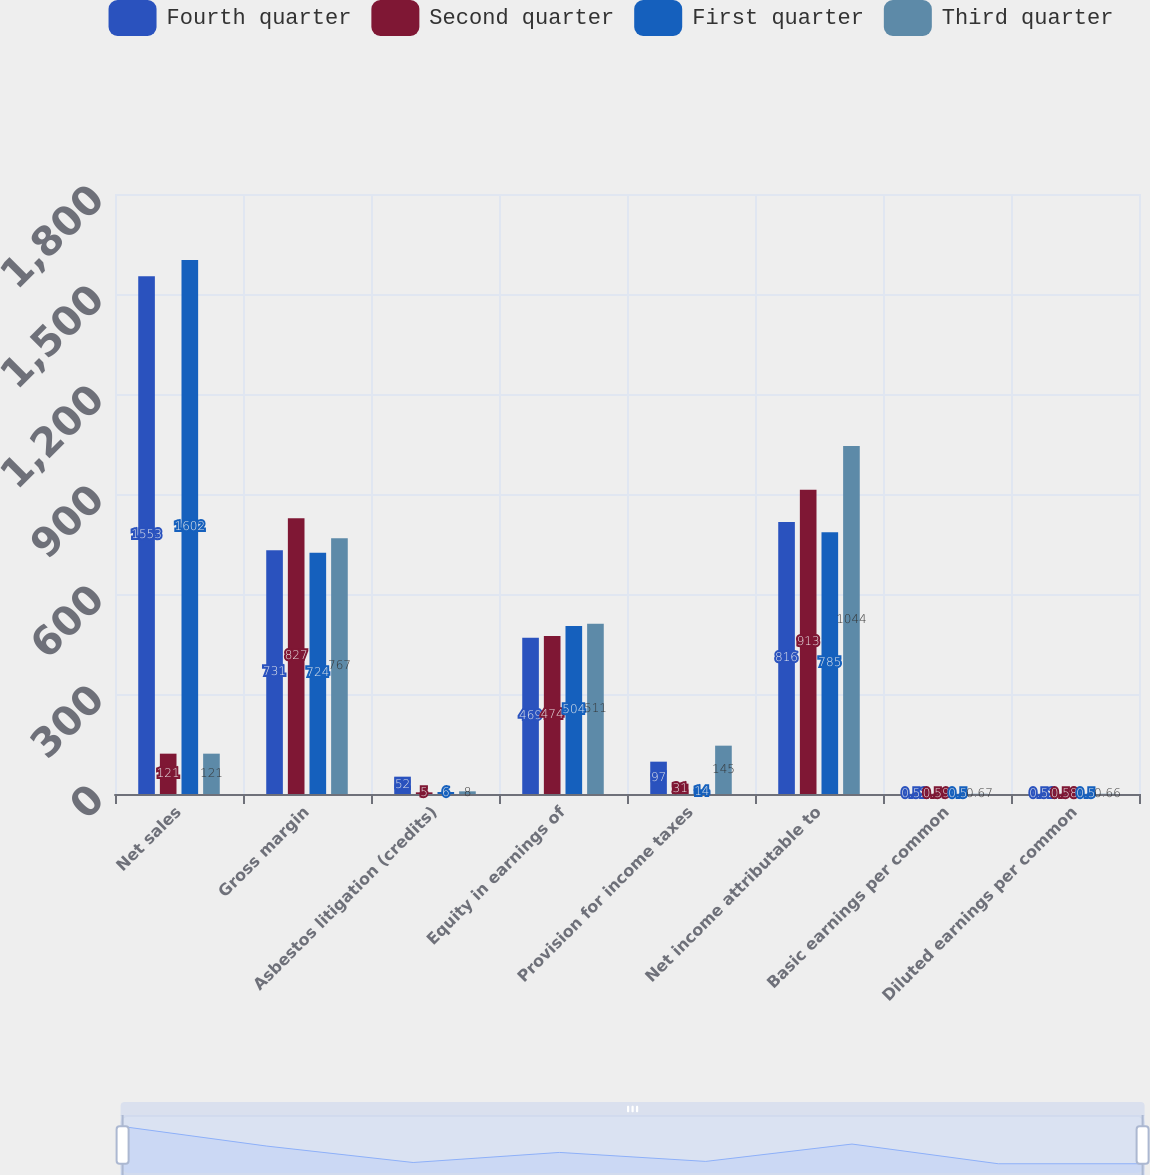Convert chart to OTSL. <chart><loc_0><loc_0><loc_500><loc_500><stacked_bar_chart><ecel><fcel>Net sales<fcel>Gross margin<fcel>Asbestos litigation (credits)<fcel>Equity in earnings of<fcel>Provision for income taxes<fcel>Net income attributable to<fcel>Basic earnings per common<fcel>Diluted earnings per common<nl><fcel>Fourth quarter<fcel>1553<fcel>731<fcel>52<fcel>469<fcel>97<fcel>816<fcel>0.52<fcel>0.52<nl><fcel>Second quarter<fcel>121<fcel>827<fcel>5<fcel>474<fcel>31<fcel>913<fcel>0.59<fcel>0.58<nl><fcel>First quarter<fcel>1602<fcel>724<fcel>6<fcel>504<fcel>14<fcel>785<fcel>0.5<fcel>0.5<nl><fcel>Third quarter<fcel>121<fcel>767<fcel>8<fcel>511<fcel>145<fcel>1044<fcel>0.67<fcel>0.66<nl></chart> 